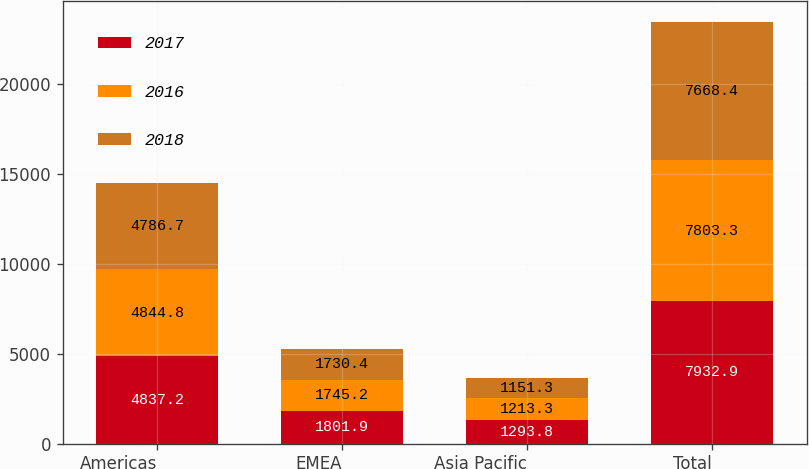Convert chart. <chart><loc_0><loc_0><loc_500><loc_500><stacked_bar_chart><ecel><fcel>Americas<fcel>EMEA<fcel>Asia Pacific<fcel>Total<nl><fcel>2017<fcel>4837.2<fcel>1801.9<fcel>1293.8<fcel>7932.9<nl><fcel>2016<fcel>4844.8<fcel>1745.2<fcel>1213.3<fcel>7803.3<nl><fcel>2018<fcel>4786.7<fcel>1730.4<fcel>1151.3<fcel>7668.4<nl></chart> 